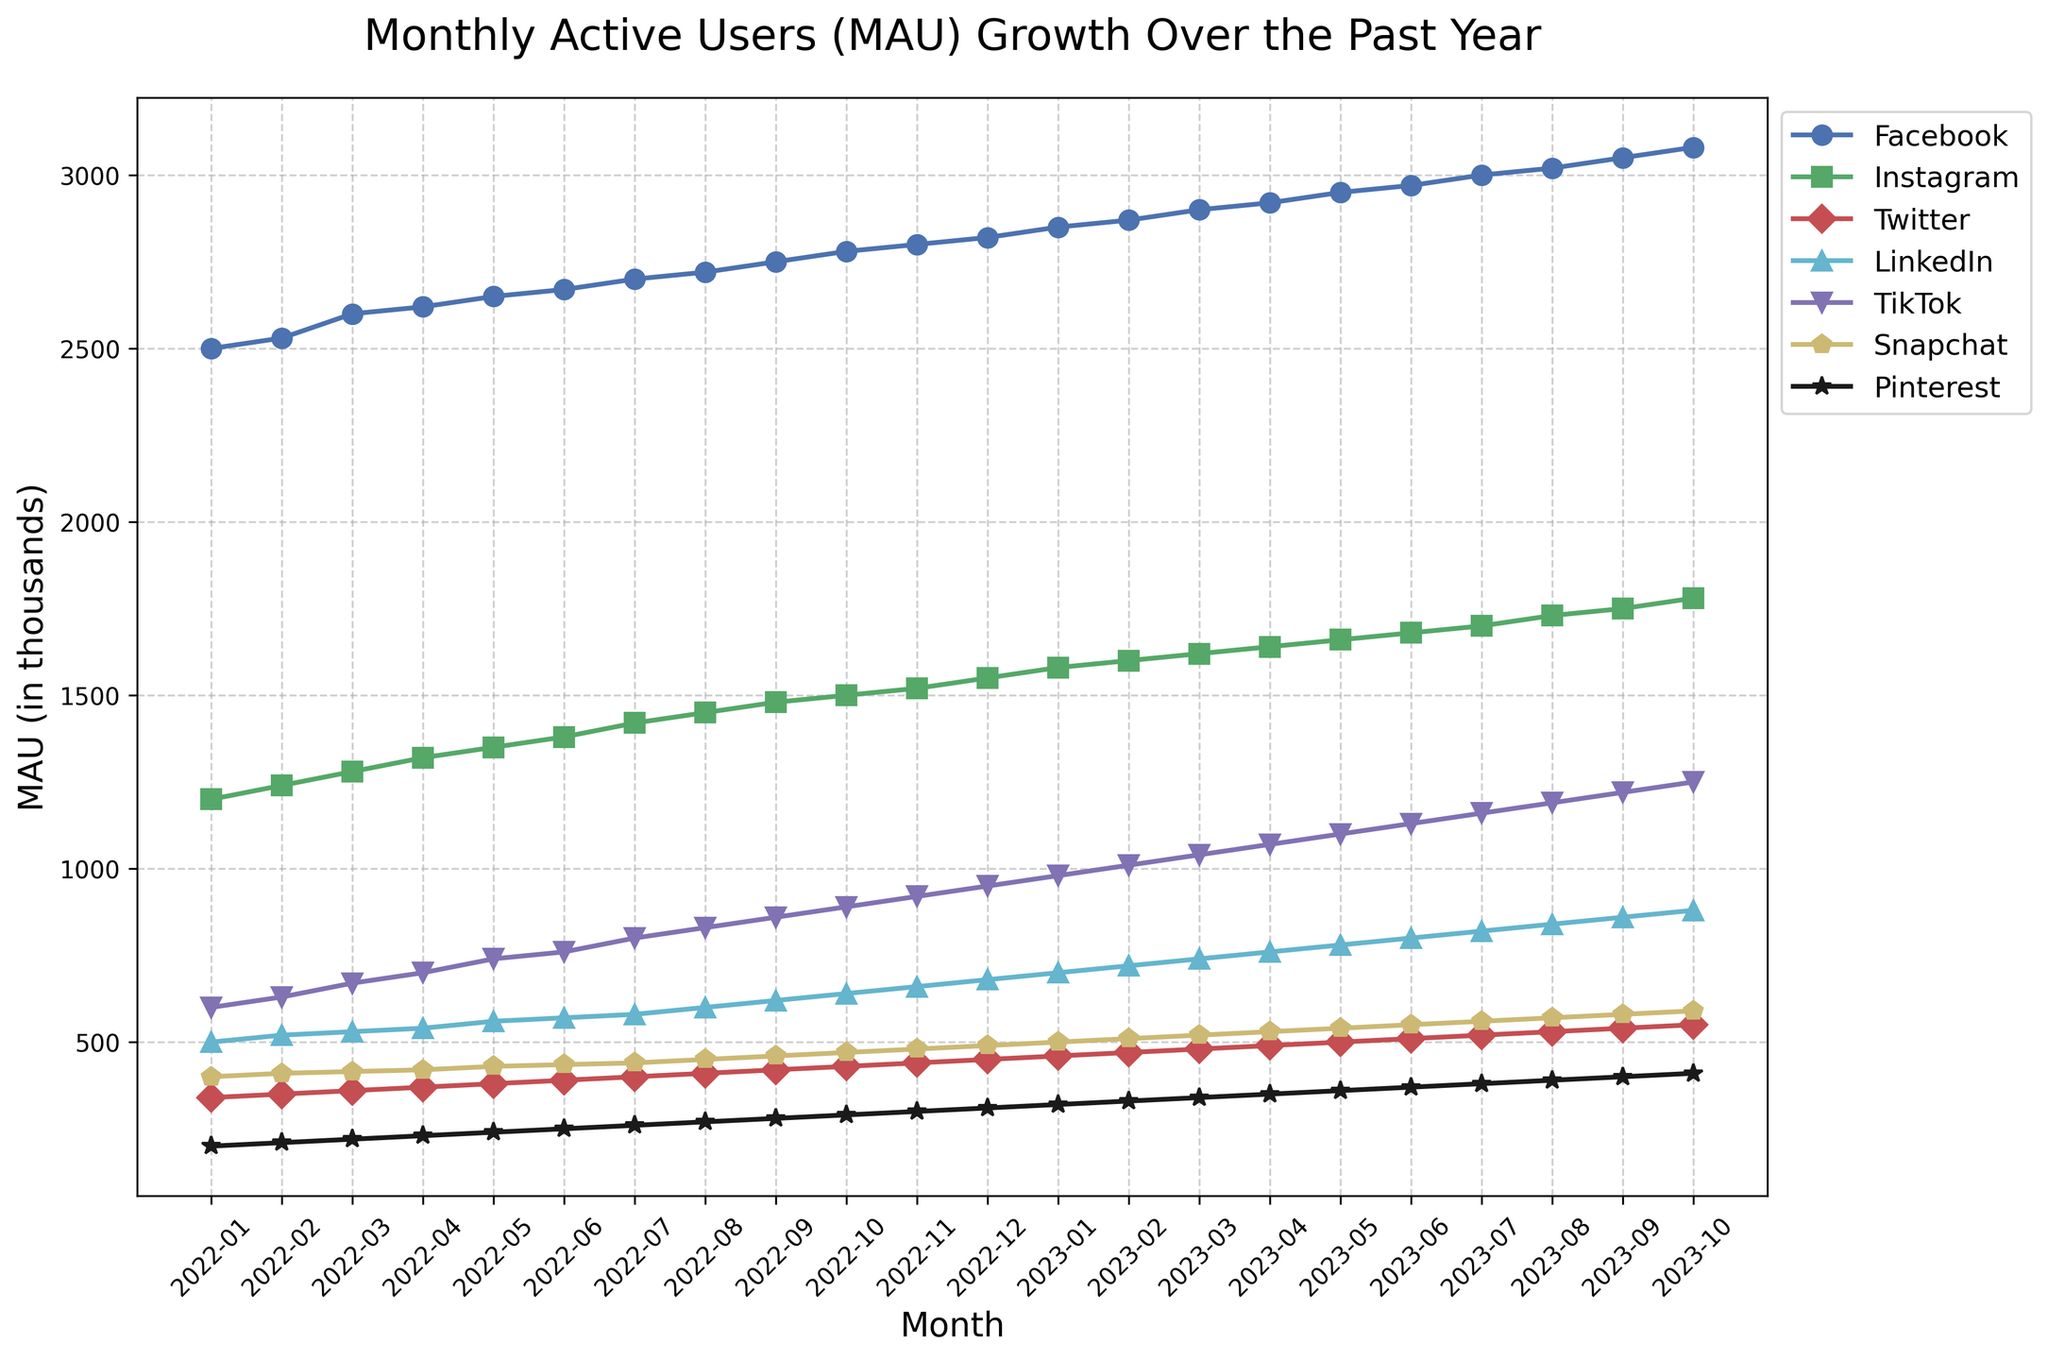What's the average MAU for Facebook over the past year? To find the average, add up all the MAUs for Facebook from January 2022 to October 2023, then divide by the number of months. Sum: 2500 + 2530 + 2600 + 2620 + 2650 + 2670 + 2700 + 2720 + 2750 + 2780 + 2800 + 2820 + 2850 + 2870 + 2900 + 2920 + 2950 + 2970 + 3000 + 3020 + 3050 + 3080 = 61200. Average = 61200 / 22
Answer: 2781.8 Between Instagram and TikTok, which platform had higher MAU in June 2023? Look at the data points for June 2023 for both Instagram and TikTok. Instagram has 1680 and TikTok has 1130.
Answer: Instagram Which platform had the fastest growth rate in MAUs over the period? Compare the increase in MAUs from January 2022 to October 2023 for each platform. Calculate the difference and order them: Facebook: 580, Instagram: 580, Twitter: 210, LinkedIn: 380, TikTok: 650, Snapchat: 190, Pinterest: 210. TikTok has the highest increase.
Answer: TikTok What's the total MAU for Snapchat and Pinterest combined in December 2022? Add the MAUs for Snapchat and Pinterest in December 2022. Snapchat: 490, Pinterest: 310. Total = 490 + 310 = 800
Answer: 800 Is there any month where all platforms experienced a growth in MAUs compared to the previous month? Compare each month's MAUs to the previous month's for all platforms. Check one by one each month. In December 2022, each platform experienced growth from the previous month in November 2022.
Answer: Yes, December 2022 How many months did Pinterest exceed a 20 MAU increase compared to the previous month? Check the monthly increase for Pinterest and count how many times the increase exceeded 20. It happened in months: March 2022, August 2022, February 2023, May 2023, and June 2023.
Answer: 5 What is the difference in MAUs between Facebook and LinkedIn in October 2023? Subtract LinkedIn’s MAUs from Facebook’s MAUs in October 2023. Facebook: 3080, LinkedIn: 880. Difference = 3080 - 880 = 2200
Answer: 2200 Which platform shows the most consistent growth in MAUs? Identify the platform with the most uniform growth pattern without large fluctuations in MAU increase each month. Facebook exhibits a steady, linear growth pattern throughout the period.
Answer: Facebook 